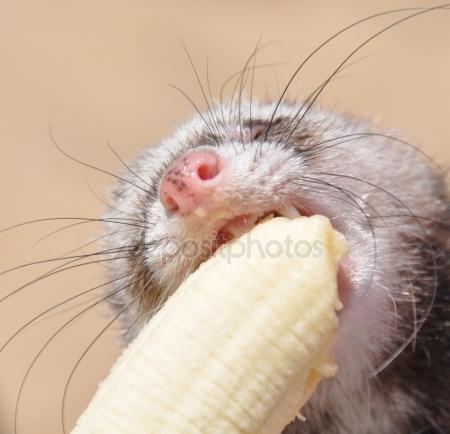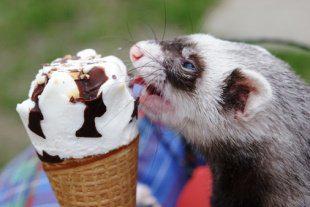The first image is the image on the left, the second image is the image on the right. Considering the images on both sides, is "There are two ferrets eating something." valid? Answer yes or no. Yes. 